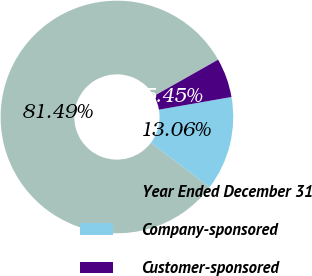Convert chart. <chart><loc_0><loc_0><loc_500><loc_500><pie_chart><fcel>Year Ended December 31<fcel>Company-sponsored<fcel>Customer-sponsored<nl><fcel>81.49%<fcel>13.06%<fcel>5.45%<nl></chart> 